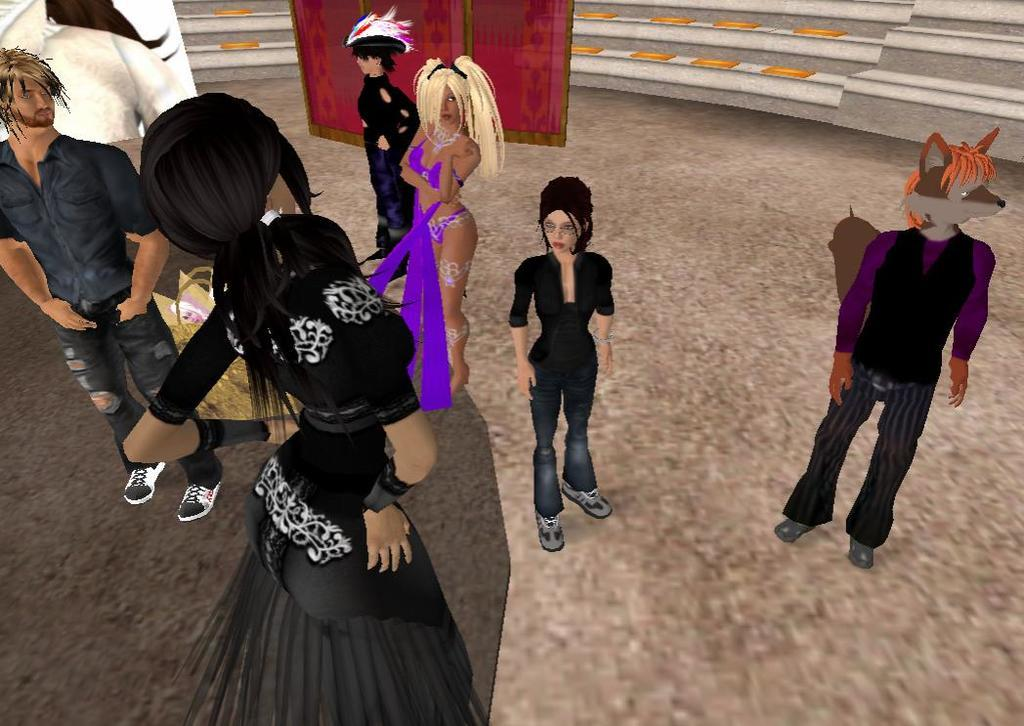What type of picture is in the image? The image contains an animated picture. What can be seen in the animated picture? There are people in the animated picture. What are the people wearing? The people are wearing different costumes. Are there any other objects present in the animated picture? Yes, there are other objects present in the animated picture. What type of nose can be seen on the cherry in the image? There is no cherry or nose present in the image; it features an animated picture with people wearing different costumes. 